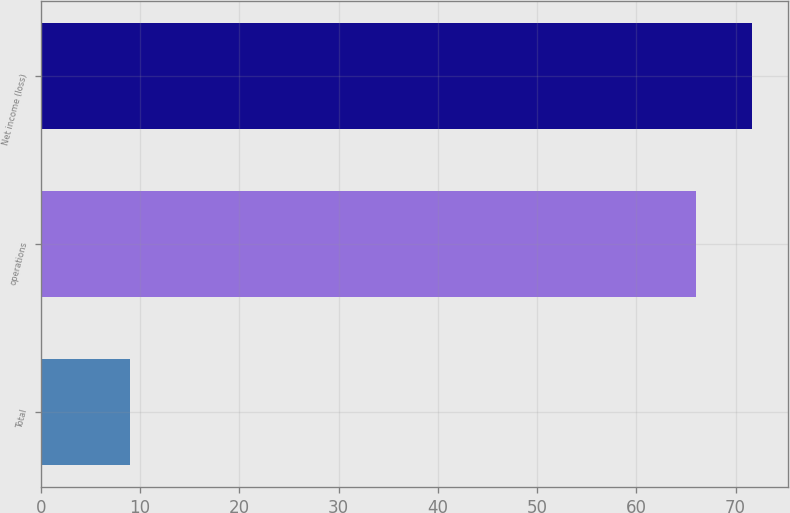<chart> <loc_0><loc_0><loc_500><loc_500><bar_chart><fcel>Total<fcel>operations<fcel>Net income (loss)<nl><fcel>9<fcel>66<fcel>71.7<nl></chart> 